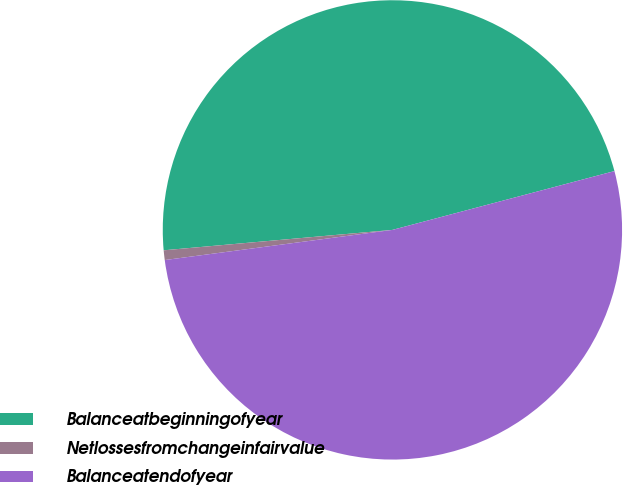Convert chart. <chart><loc_0><loc_0><loc_500><loc_500><pie_chart><fcel>Balanceatbeginningofyear<fcel>Netlossesfromchangeinfairvalue<fcel>Balanceatendofyear<nl><fcel>47.29%<fcel>0.68%<fcel>52.02%<nl></chart> 